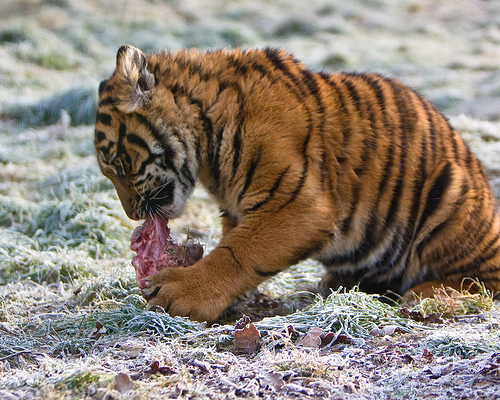<image>
Is the food on the tiger? No. The food is not positioned on the tiger. They may be near each other, but the food is not supported by or resting on top of the tiger. 